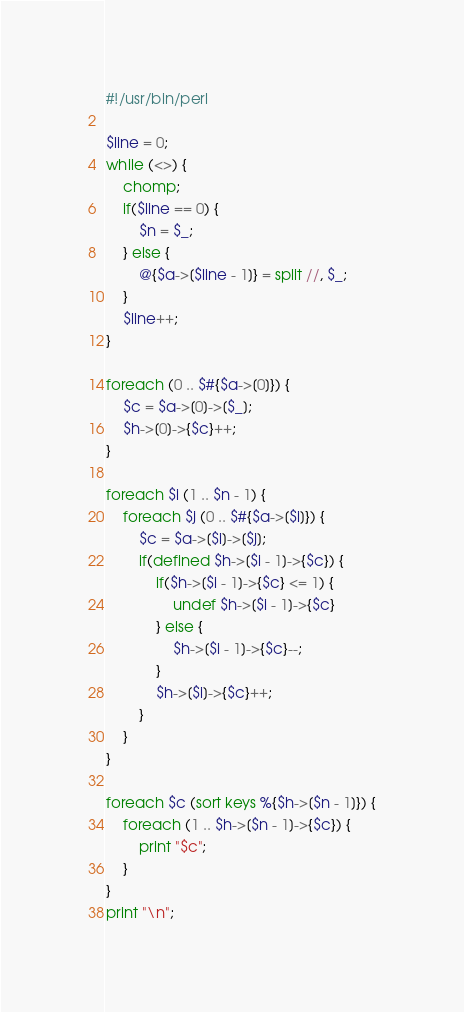Convert code to text. <code><loc_0><loc_0><loc_500><loc_500><_Perl_>#!/usr/bin/perl

$line = 0;
while (<>) {
    chomp;
    if($line == 0) {
        $n = $_;
    } else {
        @{$a->[$line - 1]} = split //, $_;
    }
    $line++;
}

foreach (0 .. $#{$a->[0]}) {
    $c = $a->[0]->[$_];
    $h->[0]->{$c}++;
}

foreach $i (1 .. $n - 1) {
    foreach $j (0 .. $#{$a->[$i]}) {
        $c = $a->[$i]->[$j];
        if(defined $h->[$i - 1]->{$c}) {
            if($h->[$i - 1]->{$c} <= 1) {
                undef $h->[$i - 1]->{$c}
            } else {
                $h->[$i - 1]->{$c}--;
            }
            $h->[$i]->{$c}++;
        }
    }
}

foreach $c (sort keys %{$h->[$n - 1]}) {
    foreach (1 .. $h->[$n - 1]->{$c}) {
        print "$c";
    }
}
print "\n";
</code> 